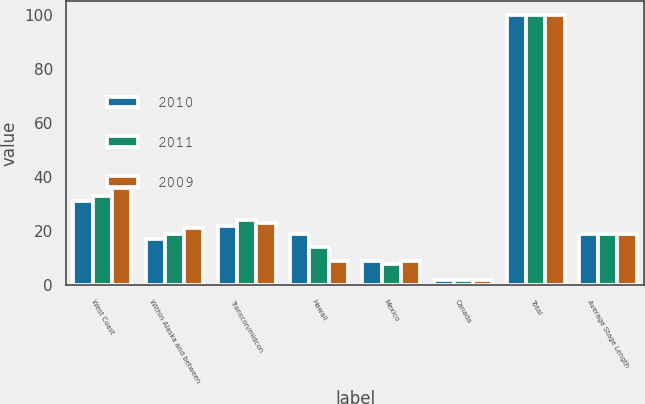<chart> <loc_0><loc_0><loc_500><loc_500><stacked_bar_chart><ecel><fcel>West Coast<fcel>Within Alaska and between<fcel>Transcon/midcon<fcel>Hawaii<fcel>Mexico<fcel>Canada<fcel>Total<fcel>Average Stage Length<nl><fcel>2010<fcel>31<fcel>17<fcel>22<fcel>19<fcel>9<fcel>2<fcel>100<fcel>19<nl><fcel>2011<fcel>33<fcel>19<fcel>24<fcel>14<fcel>8<fcel>2<fcel>100<fcel>19<nl><fcel>2009<fcel>36<fcel>21<fcel>23<fcel>9<fcel>9<fcel>2<fcel>100<fcel>19<nl></chart> 